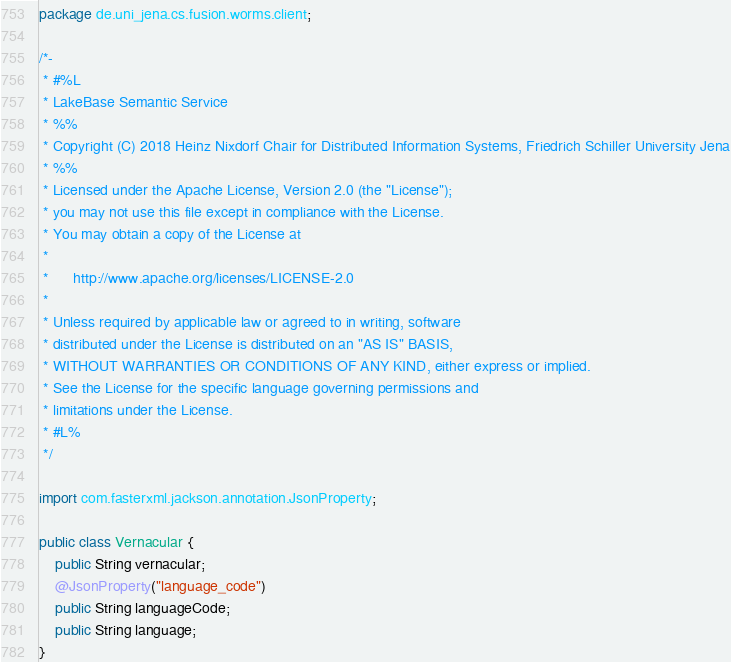Convert code to text. <code><loc_0><loc_0><loc_500><loc_500><_Java_>package de.uni_jena.cs.fusion.worms.client;

/*-
 * #%L
 * LakeBase Semantic Service
 * %%
 * Copyright (C) 2018 Heinz Nixdorf Chair for Distributed Information Systems, Friedrich Schiller University Jena
 * %%
 * Licensed under the Apache License, Version 2.0 (the "License");
 * you may not use this file except in compliance with the License.
 * You may obtain a copy of the License at
 * 
 *      http://www.apache.org/licenses/LICENSE-2.0
 * 
 * Unless required by applicable law or agreed to in writing, software
 * distributed under the License is distributed on an "AS IS" BASIS,
 * WITHOUT WARRANTIES OR CONDITIONS OF ANY KIND, either express or implied.
 * See the License for the specific language governing permissions and
 * limitations under the License.
 * #L%
 */

import com.fasterxml.jackson.annotation.JsonProperty;

public class Vernacular {
	public String vernacular;
	@JsonProperty("language_code")
	public String languageCode;
	public String language;
}
</code> 